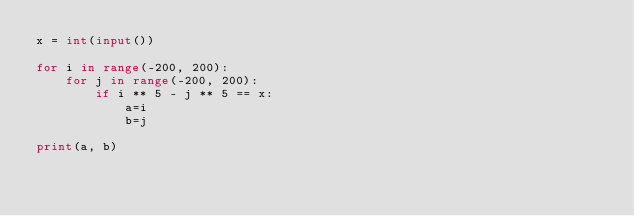<code> <loc_0><loc_0><loc_500><loc_500><_Python_>x = int(input())

for i in range(-200, 200):
    for j in range(-200, 200):
        if i ** 5 - j ** 5 == x:
            a=i
            b=j

print(a, b)</code> 